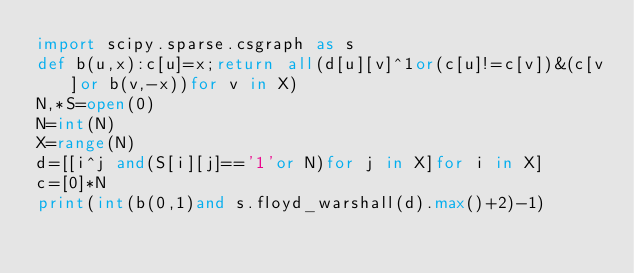Convert code to text. <code><loc_0><loc_0><loc_500><loc_500><_Python_>import scipy.sparse.csgraph as s
def b(u,x):c[u]=x;return all(d[u][v]^1or(c[u]!=c[v])&(c[v]or b(v,-x))for v in X)
N,*S=open(0)
N=int(N)
X=range(N)
d=[[i^j and(S[i][j]=='1'or N)for j in X]for i in X]
c=[0]*N
print(int(b(0,1)and s.floyd_warshall(d).max()+2)-1)
</code> 